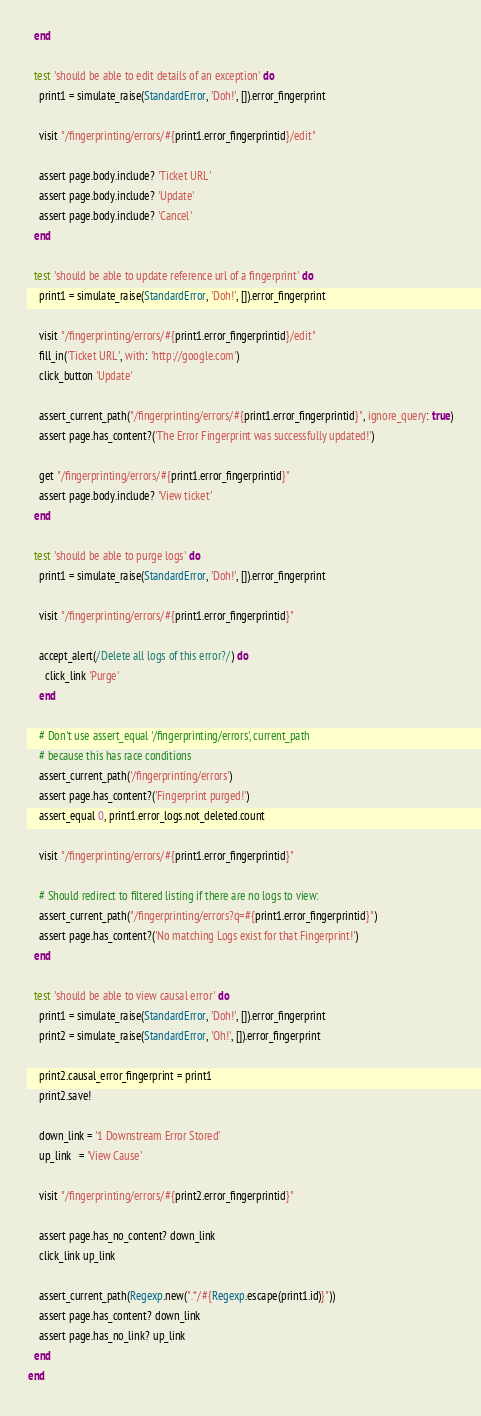Convert code to text. <code><loc_0><loc_0><loc_500><loc_500><_Ruby_>  end

  test 'should be able to edit details of an exception' do
    print1 = simulate_raise(StandardError, 'Doh!', []).error_fingerprint

    visit "/fingerprinting/errors/#{print1.error_fingerprintid}/edit"

    assert page.body.include? 'Ticket URL'
    assert page.body.include? 'Update'
    assert page.body.include? 'Cancel'
  end

  test 'should be able to update reference url of a fingerprint' do
    print1 = simulate_raise(StandardError, 'Doh!', []).error_fingerprint

    visit "/fingerprinting/errors/#{print1.error_fingerprintid}/edit"
    fill_in('Ticket URL', with: 'http://google.com')
    click_button 'Update'

    assert_current_path("/fingerprinting/errors/#{print1.error_fingerprintid}", ignore_query: true)
    assert page.has_content?('The Error Fingerprint was successfully updated!')

    get "/fingerprinting/errors/#{print1.error_fingerprintid}"
    assert page.body.include? 'View ticket'
  end

  test 'should be able to purge logs' do
    print1 = simulate_raise(StandardError, 'Doh!', []).error_fingerprint

    visit "/fingerprinting/errors/#{print1.error_fingerprintid}"

    accept_alert(/Delete all logs of this error?/) do
      click_link 'Purge'
    end

    # Don't use assert_equal '/fingerprinting/errors', current_path
    # because this has race conditions
    assert_current_path('/fingerprinting/errors')
    assert page.has_content?('Fingerprint purged!')
    assert_equal 0, print1.error_logs.not_deleted.count

    visit "/fingerprinting/errors/#{print1.error_fingerprintid}"

    # Should redirect to filtered listing if there are no logs to view:
    assert_current_path("/fingerprinting/errors?q=#{print1.error_fingerprintid}")
    assert page.has_content?('No matching Logs exist for that Fingerprint!')
  end

  test 'should be able to view causal error' do
    print1 = simulate_raise(StandardError, 'Doh!', []).error_fingerprint
    print2 = simulate_raise(StandardError, 'Oh!', []).error_fingerprint

    print2.causal_error_fingerprint = print1
    print2.save!

    down_link = '1 Downstream Error Stored'
    up_link   = 'View Cause'

    visit "/fingerprinting/errors/#{print2.error_fingerprintid}"

    assert page.has_no_content? down_link
    click_link up_link

    assert_current_path(Regexp.new(".*/#{Regexp.escape(print1.id)}"))
    assert page.has_content? down_link
    assert page.has_no_link? up_link
  end
end
</code> 